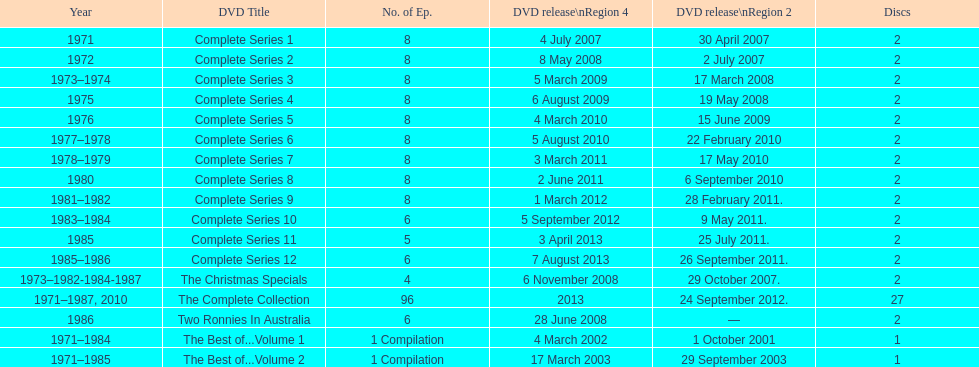Total number of episodes released in region 2 in 2007 20. 